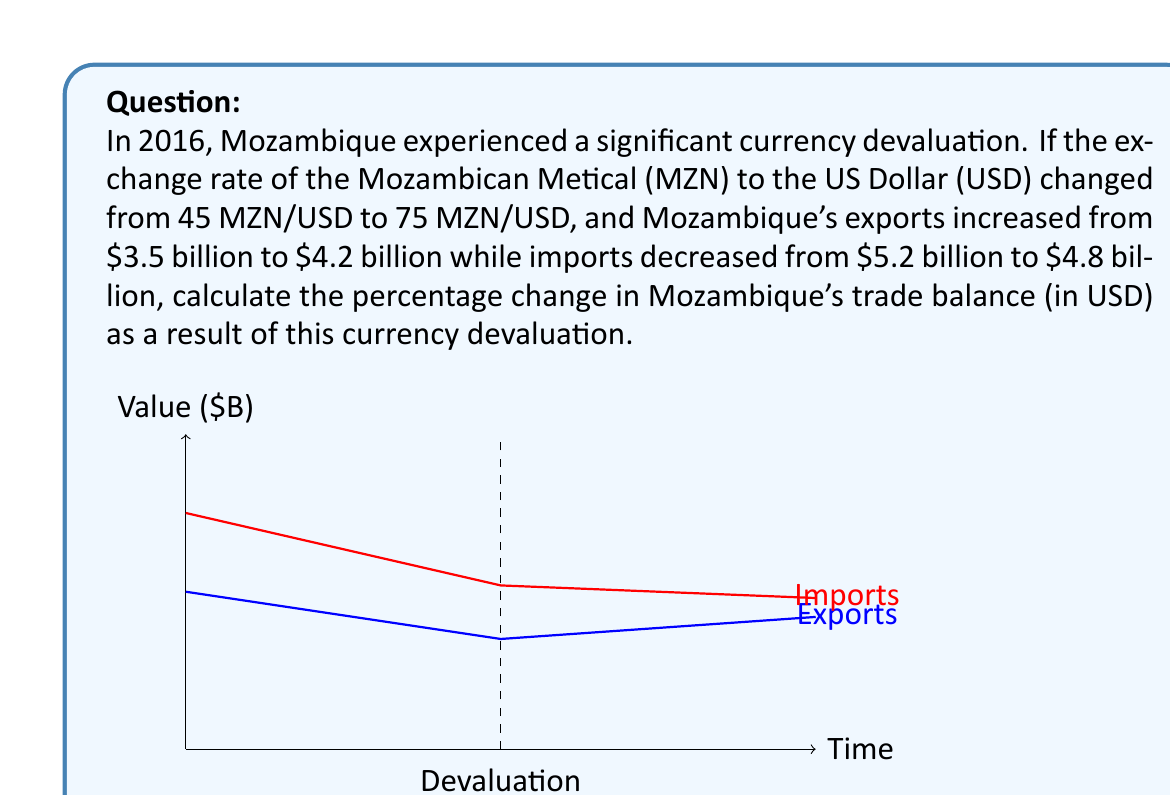Could you help me with this problem? Let's approach this step-by-step:

1) First, we need to calculate the trade balance before and after the devaluation:

   Before devaluation:
   Trade Balance = Exports - Imports
   $$ TB_{before} = $3.5B - $5.2B = -$1.7B $$

   After devaluation:
   $$ TB_{after} = $4.2B - $4.8B = -$0.6B $$

2) Now, we need to calculate the change in trade balance:
   $$ \Delta TB = TB_{after} - TB_{before} = -$0.6B - (-$1.7B) = $1.1B $$

3) To calculate the percentage change, we use the formula:
   $$ \text{Percentage Change} = \frac{\Delta TB}{|TB_{before}|} \times 100\% $$

4) Plugging in our values:
   $$ \text{Percentage Change} = \frac{$1.1B}{|-$1.7B|} \times 100\% = \frac{1.1}{1.7} \times 100\% \approx 64.71\% $$

Therefore, the trade balance improved by approximately 64.71% as a result of the currency devaluation.
Answer: 64.71% 